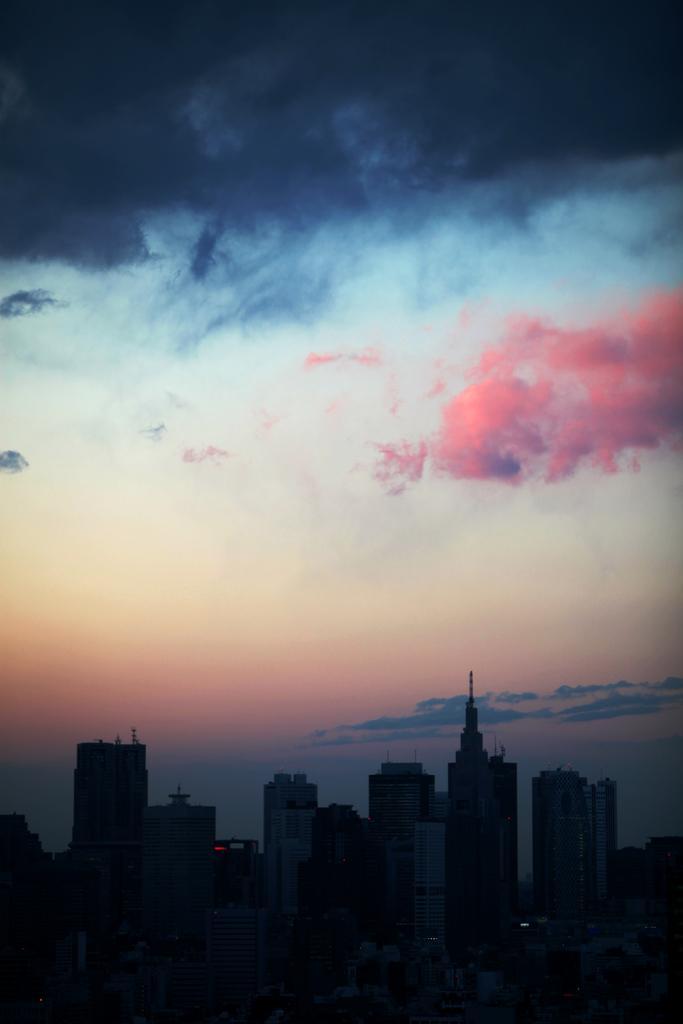How would you summarize this image in a sentence or two? At the bottom of the image we can see buildings. In the background there is sky with clouds. 